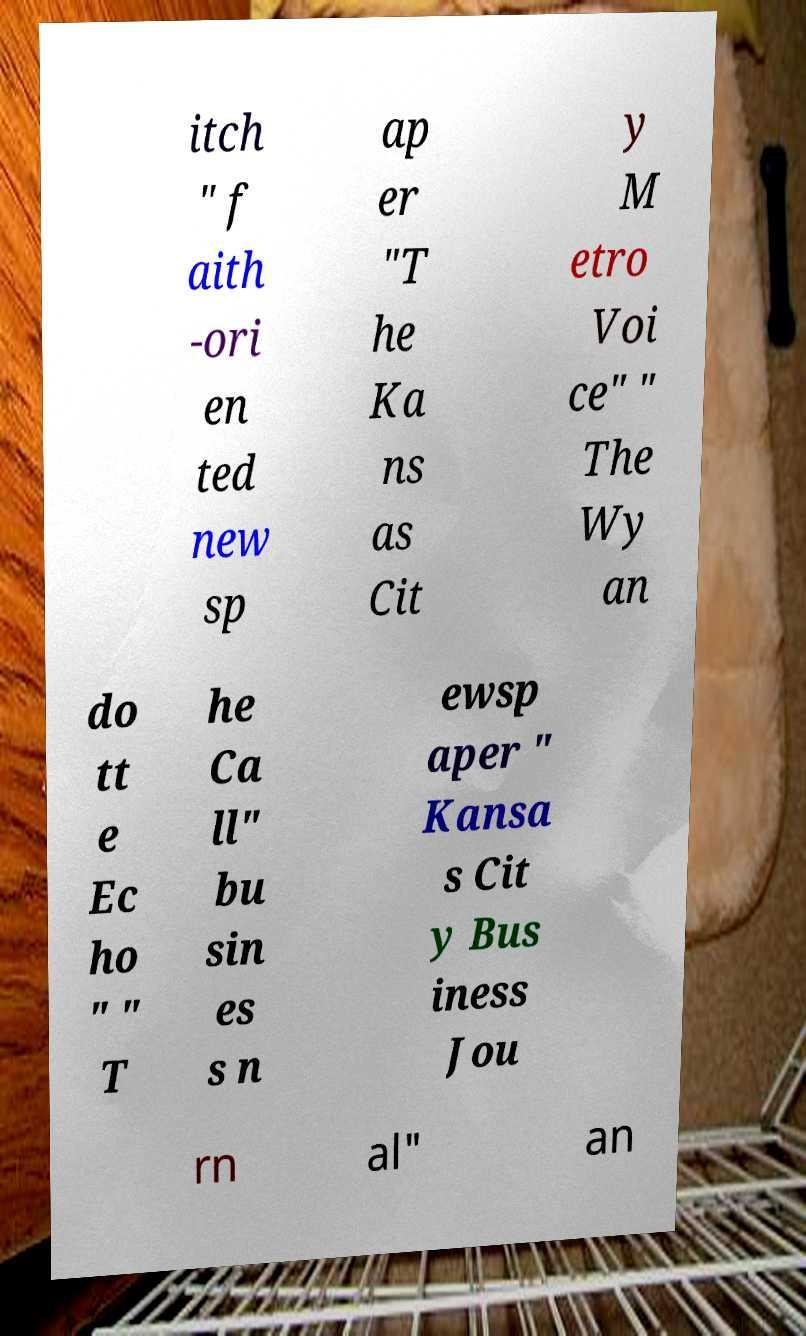I need the written content from this picture converted into text. Can you do that? itch " f aith -ori en ted new sp ap er "T he Ka ns as Cit y M etro Voi ce" " The Wy an do tt e Ec ho " " T he Ca ll" bu sin es s n ewsp aper " Kansa s Cit y Bus iness Jou rn al" an 